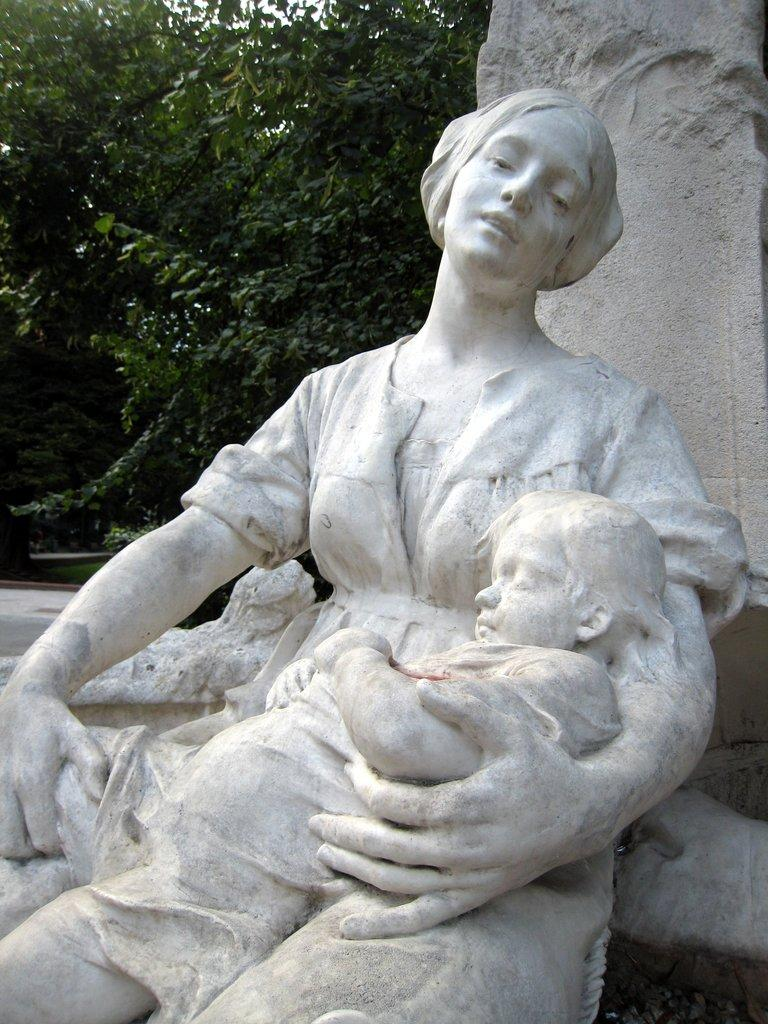What is the main subject of the image? There is a woman statue in the image. What is the woman statue holding? The woman statue is holding a baby on her lap. What can be seen behind the statue? There is a wall behind the statue. What type of vegetation is on the left side of the image? There are trees on the left side of the image. What organization does the governor represent in the image? There is no governor or organization present in the image; it features a woman statue holding a baby with a wall and trees in the background. 